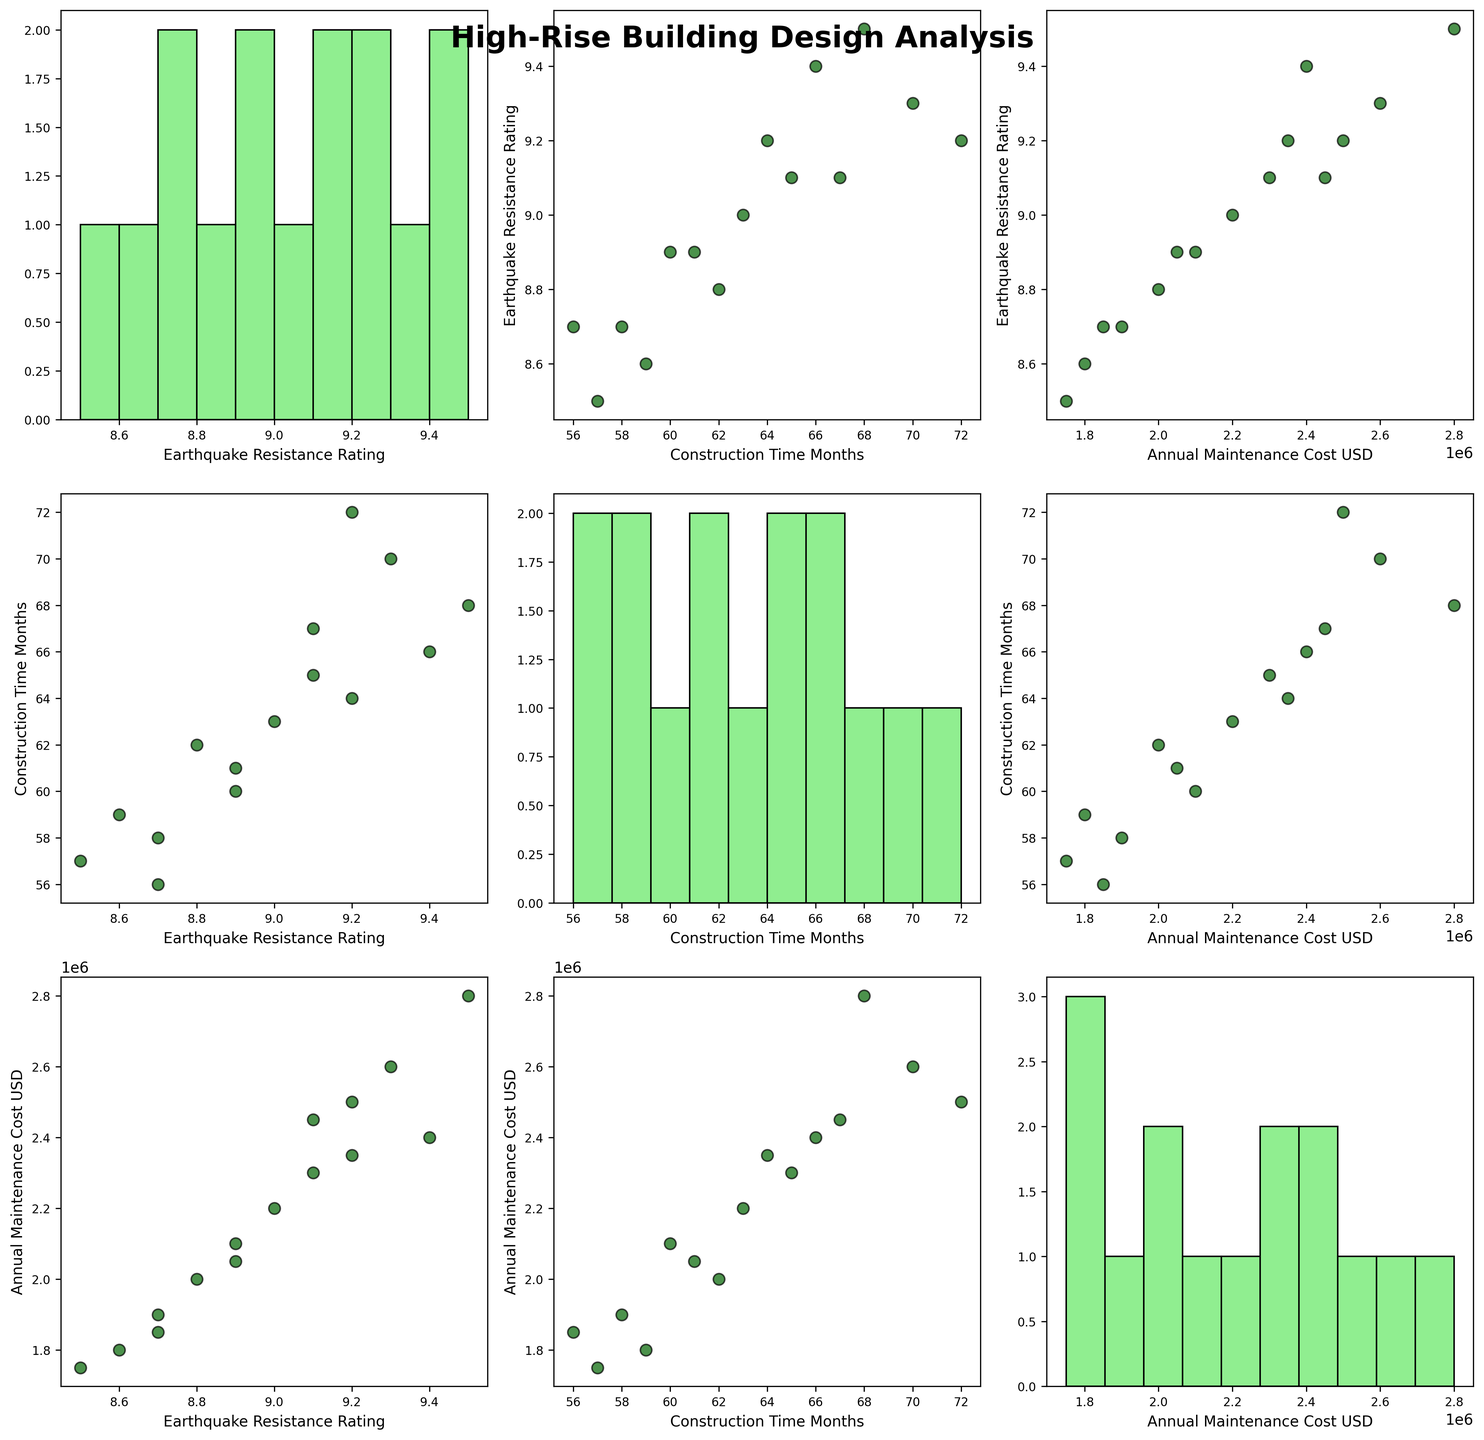What's the title of the figure? The title of the figure is found at the top of the plot. It is often in bold and larger font than other text elements.
Answer: High-Rise Building Design Analysis How many data points are there in the scatterplot between Earthquake Resistance Rating and Construction Time? You can count the number of individual dots in the scatterplot between Earthquake Resistance Rating and Construction Time axes.
Answer: 15 What color are the scatter points in the plot? The scatter points in the plots are colored consistently. Looking at one of the scatter plots, you can see that they're green.
Answer: dark green What's the highest frequency bin in the histogram of Annual Maintenance Cost USD? Find the histogram in the scatterplot matrix for Annual Maintenance Cost USD and identify the bin with the tallest bar.
Answer: The bin around 2,000,000 USD has the highest frequency What are the axes labels for the scatter plot between Annual Maintenance Cost USD and Construction Time Months? Look at the bottom row and third column of the scatterplot matrix. The x-axis is labeled with the variable in the column, and the y-axis is labeled with the variable in the row.
Answer: x-axis: Annual Maintenance Cost USD; y-axis: Construction Time Months Which building design has the highest Earthquake Resistance Rating? Seek the highest value on the y-axis of the scatterplot involving Earthquake Resistance Rating and match it to the data point. Verify with an additional data column in the dataframe.
Answer: Shanghai Tower Model Is there a general trend between Earthquake Resistance Rating and Construction Time Months? By observing the relationship between the two variables in their scatterplot, you can notice if the points show an upward or downward trend.
Answer: No clear trend Which building design takes the shortest time to construct? Find the minimum value on the x-axis of the scatterplot involving Construction Time Months and match it to the corresponding data point. Verify in the dataframe.
Answer: Kolkata The 42 Style Which building design has the lowest annual maintenance cost? Look at the minimum y-value in the histogram for Annual Maintenance Cost USD. Cross-reference it with the dataframe values.
Answer: Mumbai World One Approach 